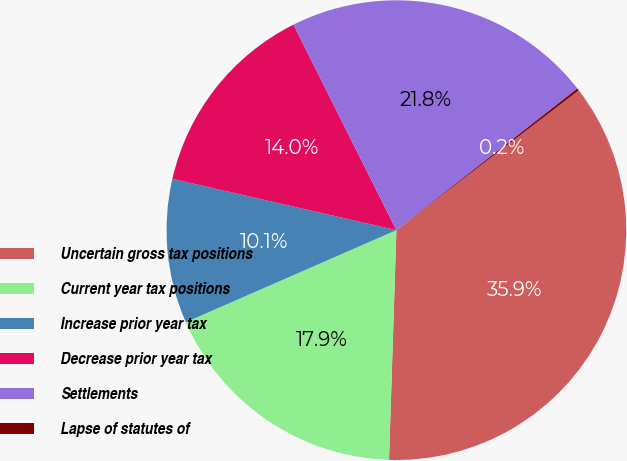<chart> <loc_0><loc_0><loc_500><loc_500><pie_chart><fcel>Uncertain gross tax positions<fcel>Current year tax positions<fcel>Increase prior year tax<fcel>Decrease prior year tax<fcel>Settlements<fcel>Lapse of statutes of<nl><fcel>35.92%<fcel>17.93%<fcel>10.14%<fcel>14.03%<fcel>21.82%<fcel>0.16%<nl></chart> 